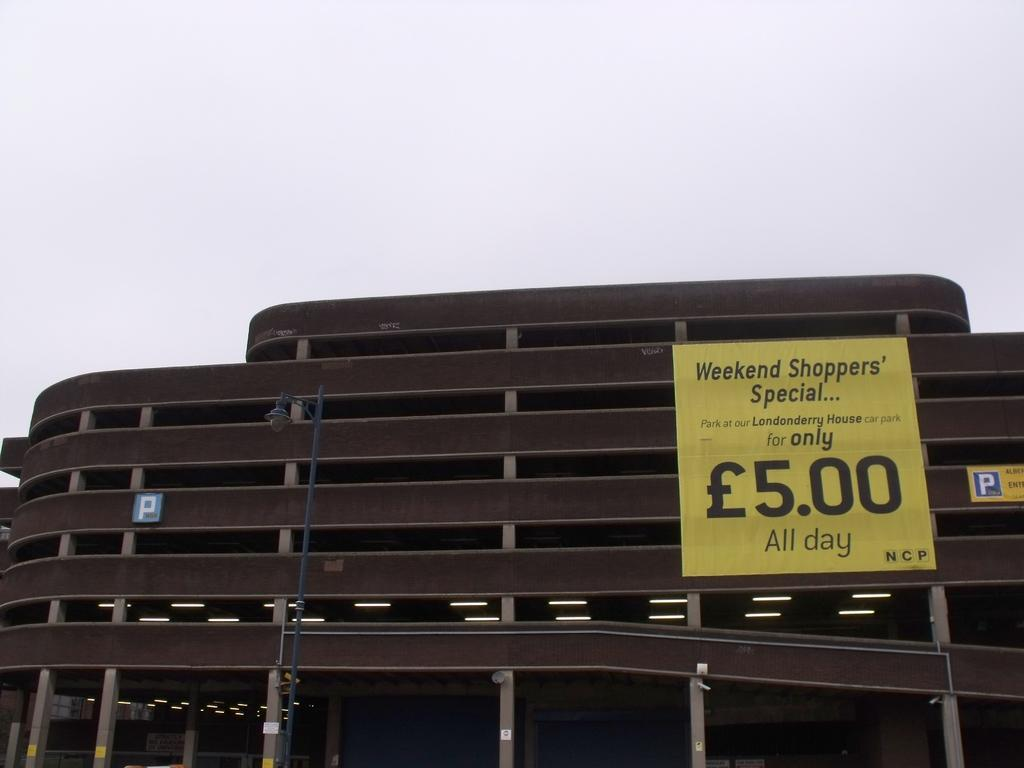What is on the pole in the image? There is a light on a pole in the image. What is on the building in the image? There are boards on a building in the image. What architectural features are present in the image? There are pillars in the image. What else can be seen in the image besides the light and boards? There are lights in the image. What can be seen in the background of the image? The sky is visible in the background of the image. What type of seed is growing on the pillars in the image? There are no seeds or plants growing on the pillars in the image; they are architectural features. What kind of toys can be seen on the boards in the image? There are no toys present in the image; it features a light on a pole, boards on a building, pillars, lights, and a visible sky. 